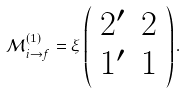<formula> <loc_0><loc_0><loc_500><loc_500>\mathcal { M } _ { i \to f } ^ { ( 1 ) } = \xi \left ( \begin{array} { c c } 2 ^ { \prime } & 2 \\ 1 ^ { \prime } & 1 \\ \end{array} \right ) .</formula> 